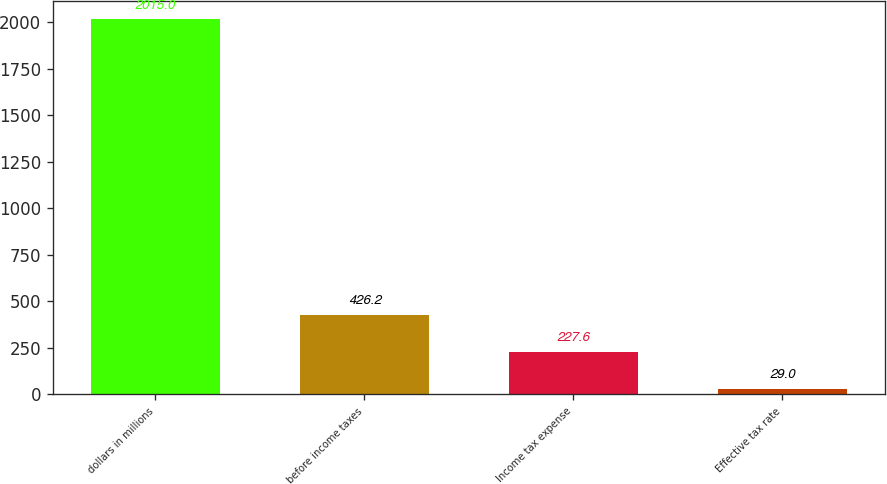Convert chart. <chart><loc_0><loc_0><loc_500><loc_500><bar_chart><fcel>dollars in millions<fcel>before income taxes<fcel>Income tax expense<fcel>Effective tax rate<nl><fcel>2015<fcel>426.2<fcel>227.6<fcel>29<nl></chart> 